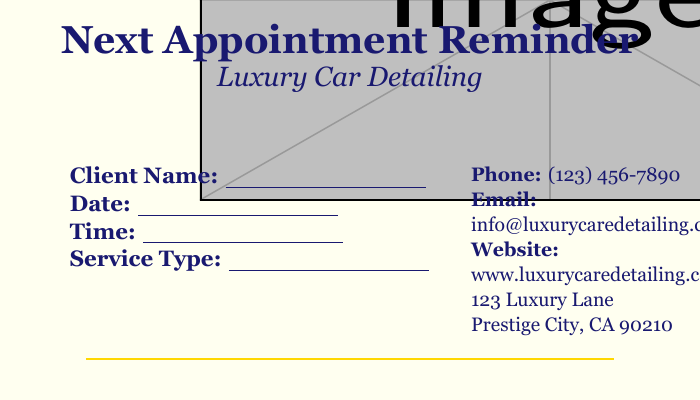what is the document title? The title is prominently displayed at the top of the document, indicating its purpose.
Answer: Next Appointment Reminder what type of service is mentioned? The type of service provided is noted in the document under luxury car detailing.
Answer: Luxury Car Detailing what information is required from the client? The document specifies a section for the client's details, indicating what information is necessary for appointment scheduling.
Answer: Client Name, Date, Time, Service Type what is the phone number listed? The contact information for the business is provided, which includes a phone number for client communication.
Answer: (123) 456-7890 in what city is the business located? The address of the business includes the city, which is crucial for identifying the business location.
Answer: Prestige City how many details are provided for the appointment? The document specifies four distinct pieces of information that need to be recorded for the appointment.
Answer: Four what color is used for the document's background? The background color of the document is designed to be visually appealing and is specified in the document's setup.
Answer: Ivory white what kind of finish does the card have? The document describes the card's design aesthetic, indicating its quality and appeal.
Answer: High-quality finish what type of font is used for the main text? The choice of font reflects the luxury branding of the car detailing business and is specified in the document.
Answer: Georgia 